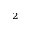<formula> <loc_0><loc_0><loc_500><loc_500>^ { 2 }</formula> 